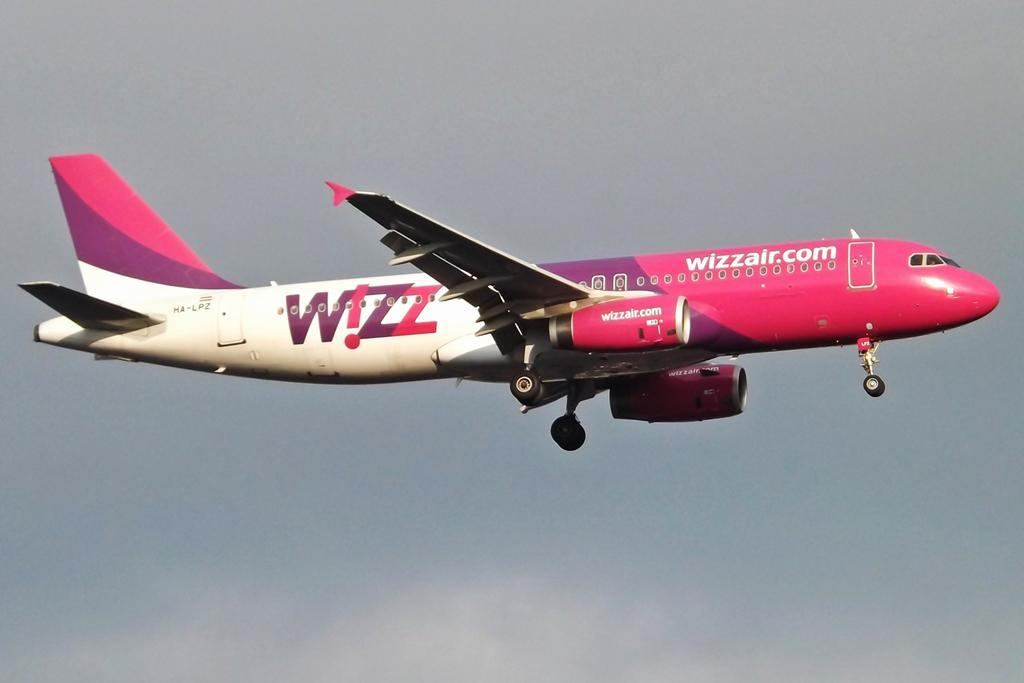<image>
Offer a succinct explanation of the picture presented. A plane has the website wizzair.com on the side of it. 